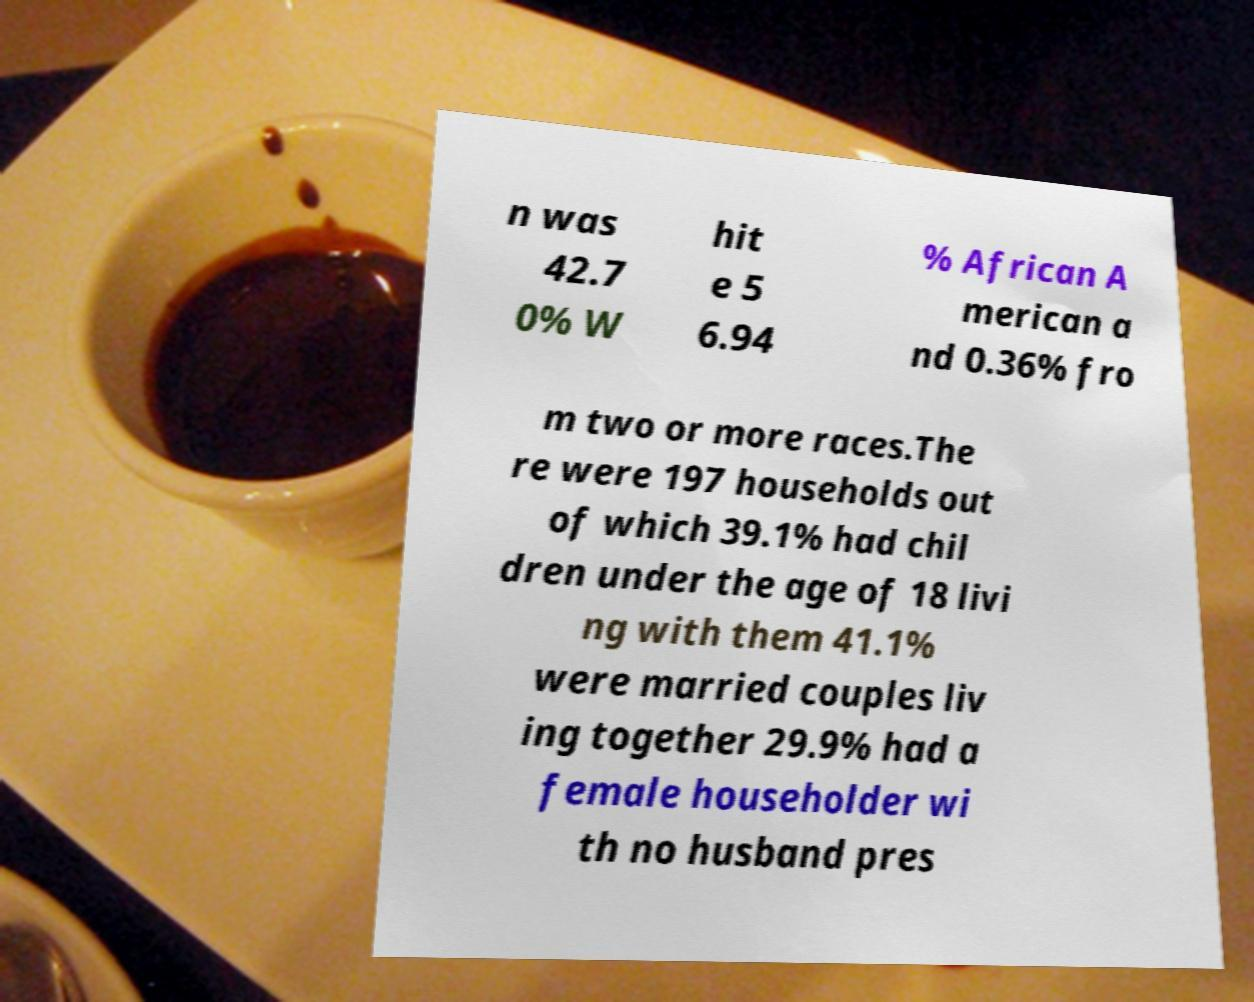Please identify and transcribe the text found in this image. n was 42.7 0% W hit e 5 6.94 % African A merican a nd 0.36% fro m two or more races.The re were 197 households out of which 39.1% had chil dren under the age of 18 livi ng with them 41.1% were married couples liv ing together 29.9% had a female householder wi th no husband pres 